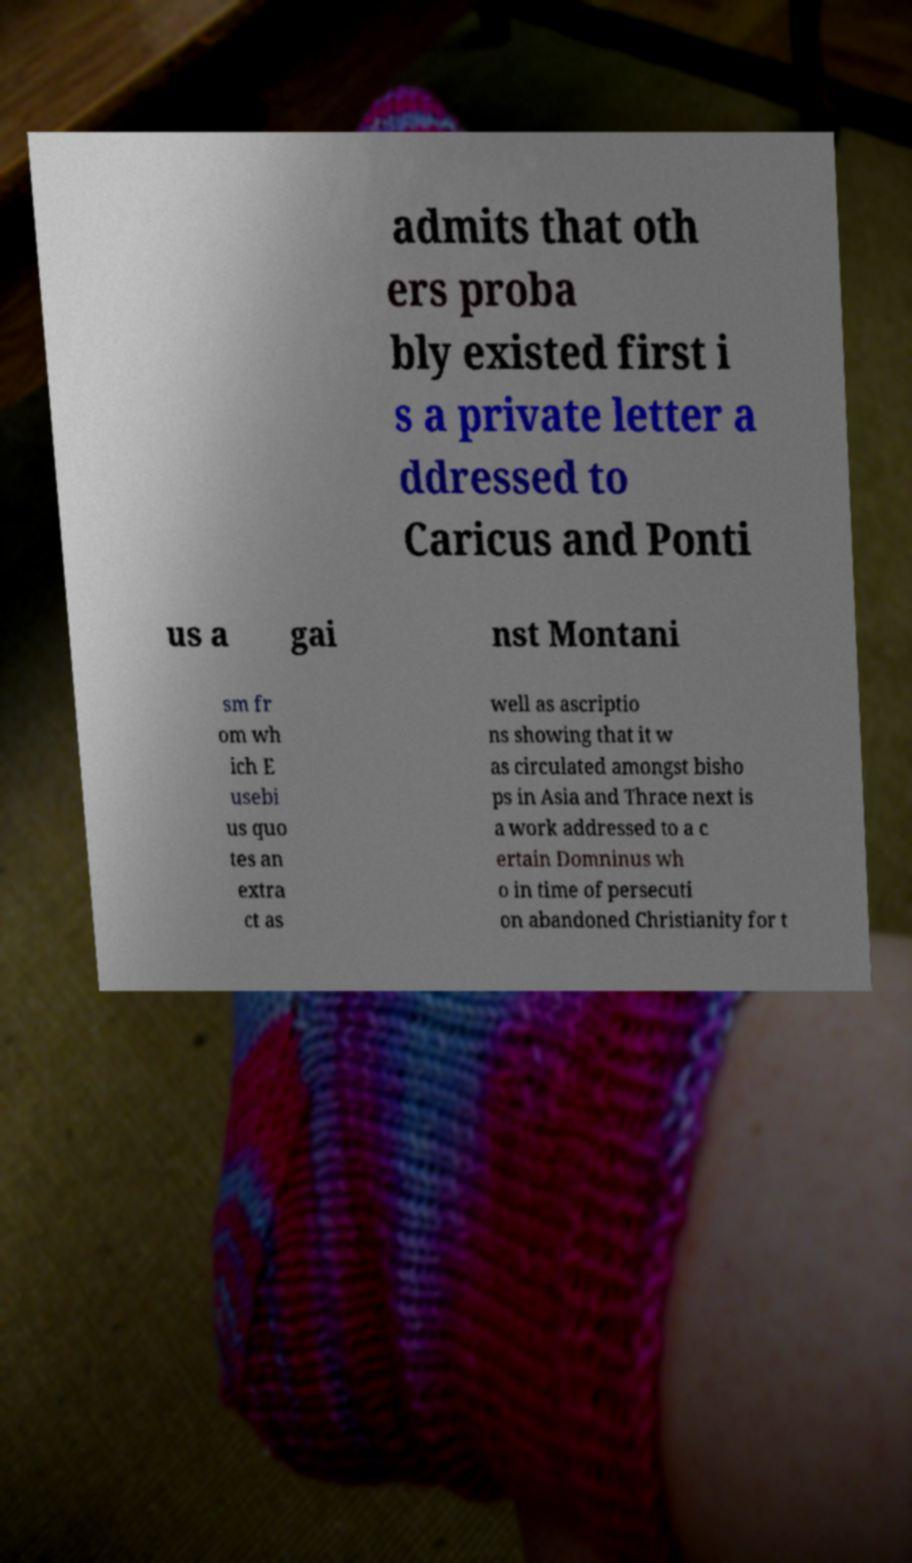Please read and relay the text visible in this image. What does it say? admits that oth ers proba bly existed first i s a private letter a ddressed to Caricus and Ponti us a gai nst Montani sm fr om wh ich E usebi us quo tes an extra ct as well as ascriptio ns showing that it w as circulated amongst bisho ps in Asia and Thrace next is a work addressed to a c ertain Domninus wh o in time of persecuti on abandoned Christianity for t 